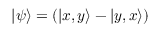Convert formula to latex. <formula><loc_0><loc_0><loc_500><loc_500>\left | \psi \right \rangle = ( \left | x , y \right \rangle - \left | y , x \right \rangle )</formula> 